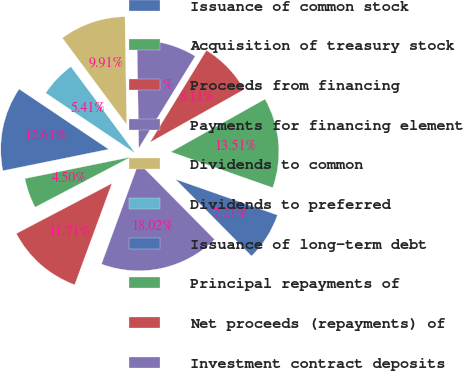Convert chart. <chart><loc_0><loc_0><loc_500><loc_500><pie_chart><fcel>Issuance of common stock<fcel>Acquisition of treasury stock<fcel>Proceeds from financing<fcel>Payments for financing element<fcel>Dividends to common<fcel>Dividends to preferred<fcel>Issuance of long-term debt<fcel>Principal repayments of<fcel>Net proceeds (repayments) of<fcel>Investment contract deposits<nl><fcel>7.21%<fcel>13.51%<fcel>8.11%<fcel>9.01%<fcel>9.91%<fcel>5.41%<fcel>12.61%<fcel>4.5%<fcel>11.71%<fcel>18.02%<nl></chart> 